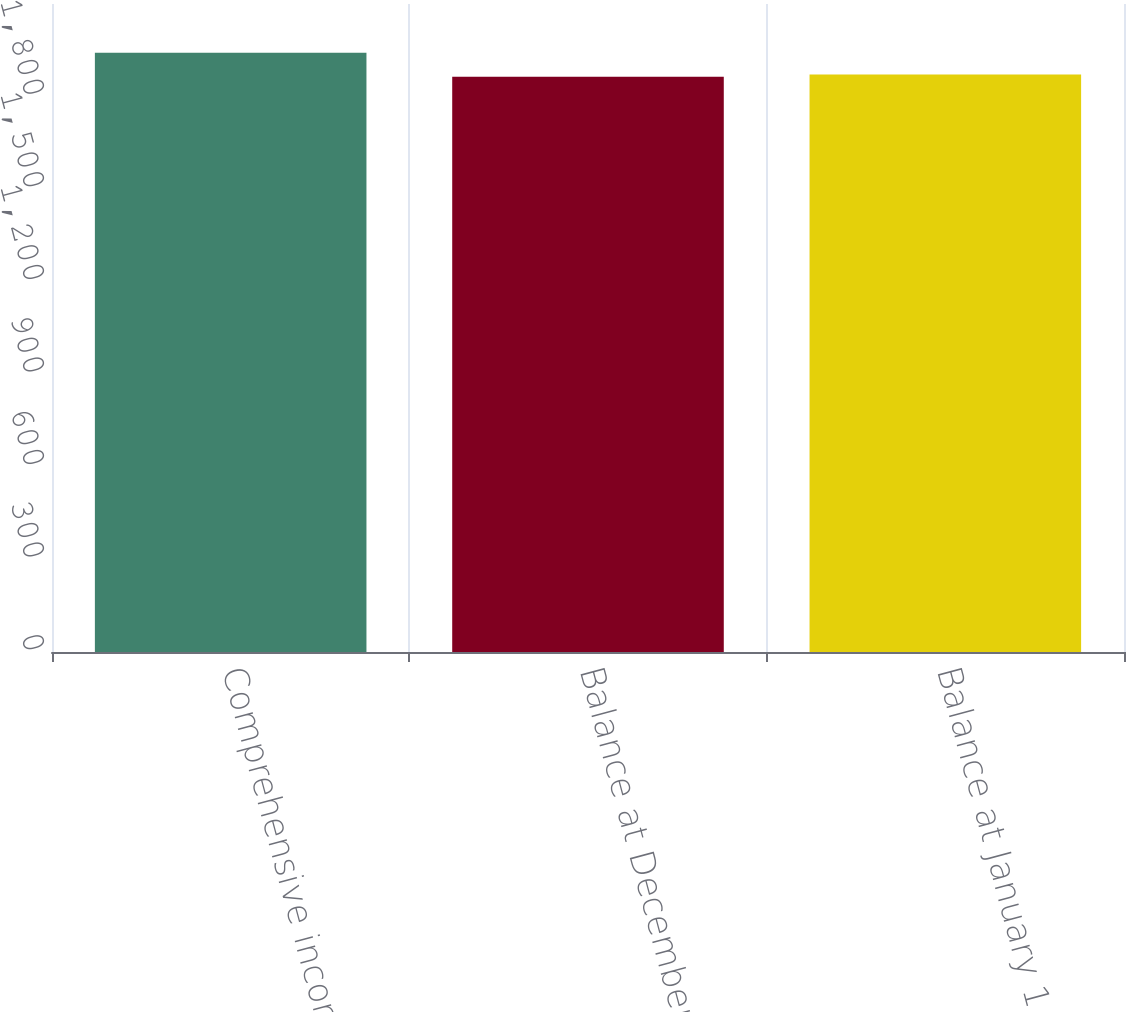Convert chart to OTSL. <chart><loc_0><loc_0><loc_500><loc_500><bar_chart><fcel>Comprehensive income<fcel>Balance at December 31 2006<fcel>Balance at January 1 2007<nl><fcel>1942<fcel>1864<fcel>1871.8<nl></chart> 